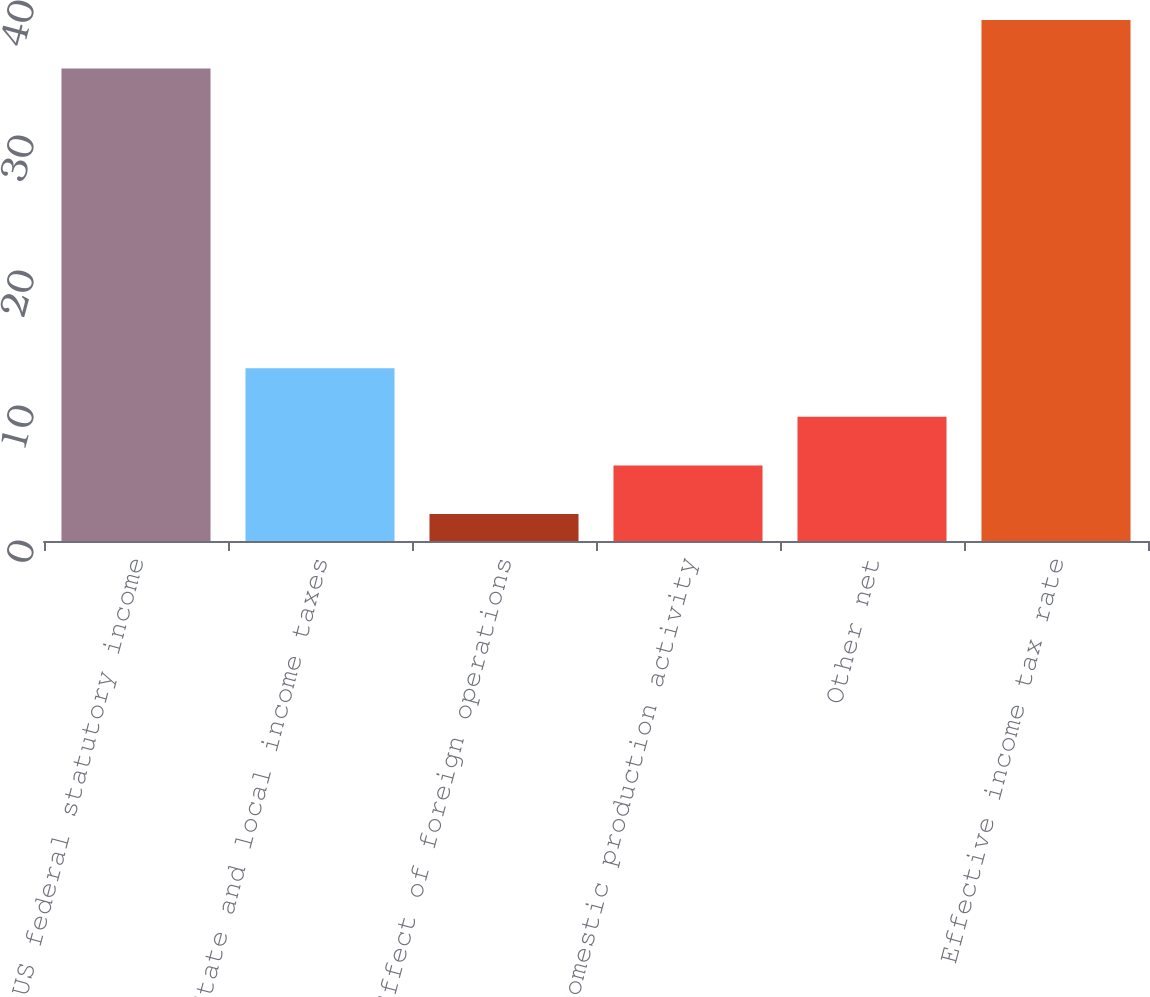<chart> <loc_0><loc_0><loc_500><loc_500><bar_chart><fcel>US federal statutory income<fcel>State and local income taxes<fcel>Effect of foreign operations<fcel>Domestic production activity<fcel>Other net<fcel>Effective income tax rate<nl><fcel>35<fcel>12.8<fcel>2<fcel>5.6<fcel>9.2<fcel>38.6<nl></chart> 